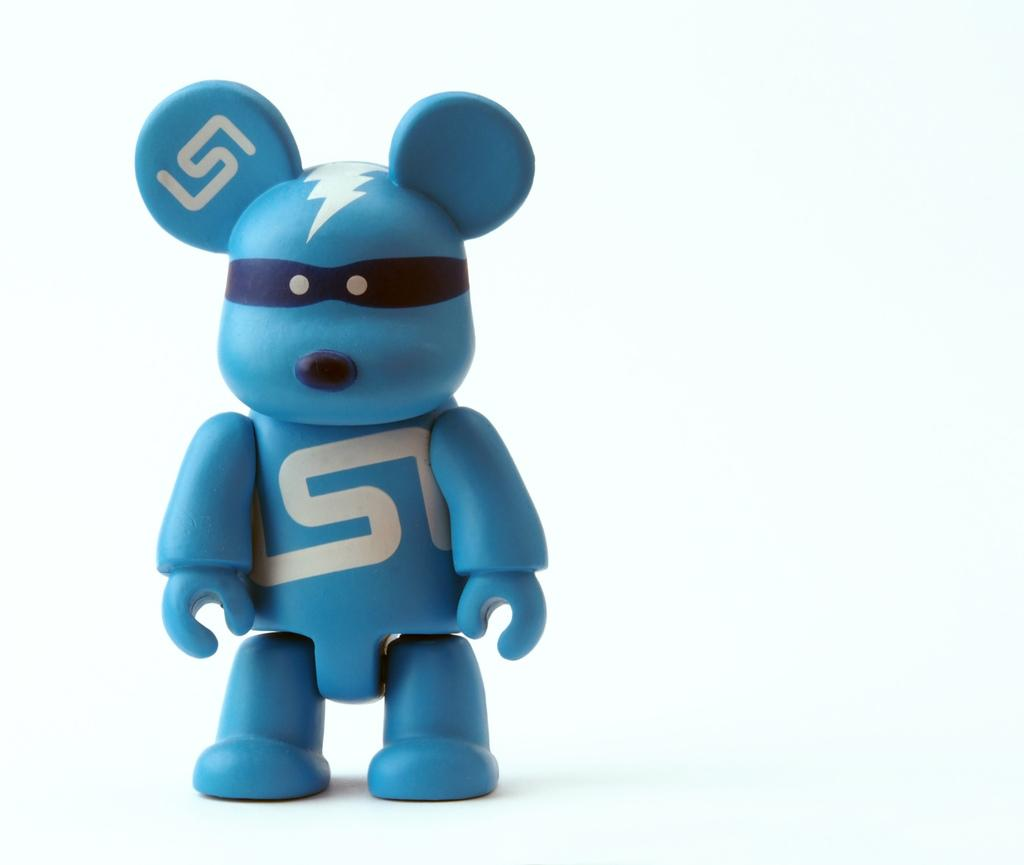What is the color of the toy in the picture? The toy in the picture is blue in color. What color is the background of the image? The background of the image is white in color. Can you see any sand in the image? There is no sand present in the image. What type of vein is visible in the image? There is no vein present in the image. 